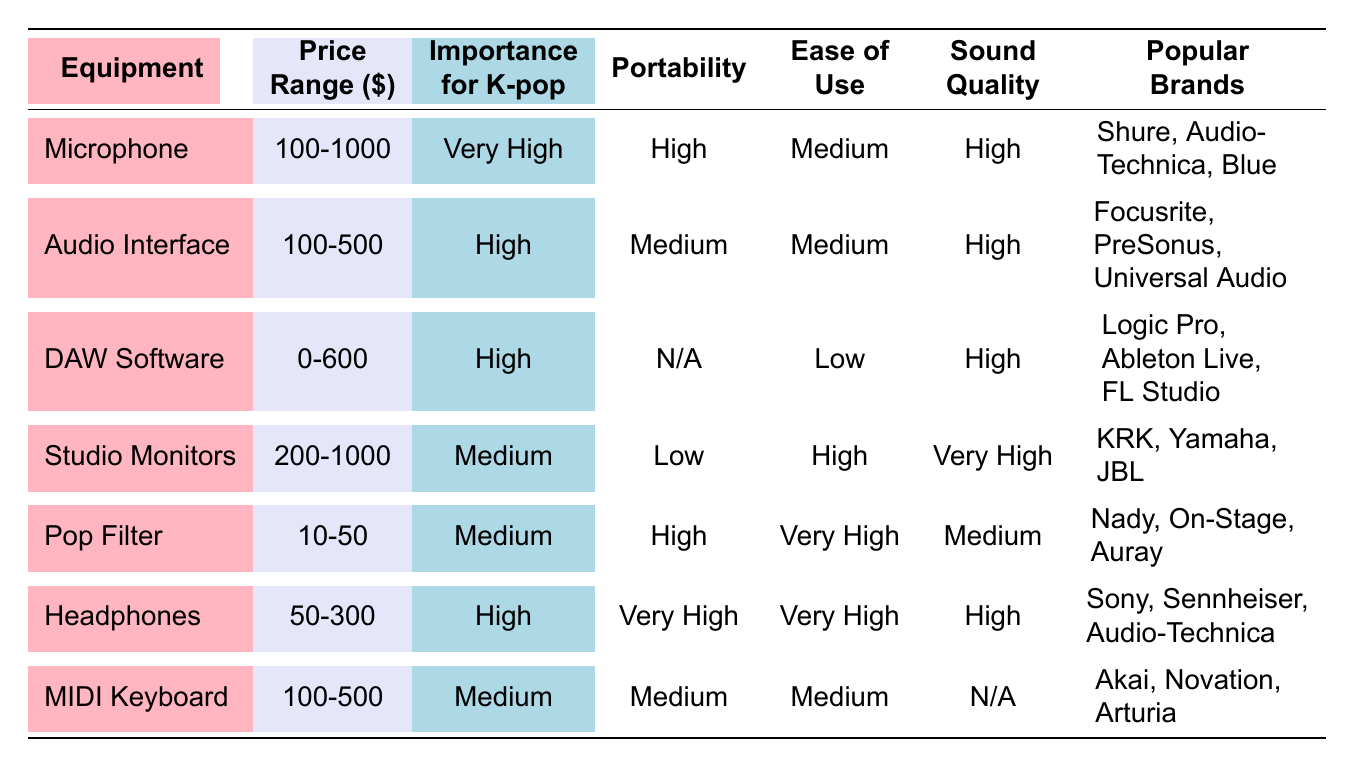What is the price range of a Pop Filter? The table lists the price range for a Pop Filter as "10-50" dollars.
Answer: 10-50 Which equipment has the highest sound quality rating? According to the table, Studio Monitors have the highest sound quality rating of "Very High."
Answer: Studio Monitors Is the importance of a Microphone for K-pop considered high? The table indicates that the importance of a Microphone for K-pop is rated as "Very High," so the answer is yes.
Answer: Yes What equipment has the lowest portability rating? The table shows that Studio Monitors have a portability rating of "Low," which is the lowest among the listed equipment.
Answer: Studio Monitors Does the DAW Software have an ease of use rating higher than the Audio Interface? The DAW Software has an ease of use rating of "Low," while the Audio Interface has "Medium." Since "Low" is not higher than "Medium," the answer is no.
Answer: No What is the average price range of all audio equipment listed? To find the average price range, we'll take all the price ranges into account: Microphone (100-1000), Audio Interface (100-500), DAW Software (0-600), Studio Monitors (200-1000), Pop Filter (10-50), Headphones (50-300), and MIDI Keyboard (100-500). Calculating the average range involves considering the minimum and maximum values separately. The minimum total is 100 + 100 + 0 + 200 + 10 + 50 + 100 = 560, and the maximum is 1000 + 500 + 600 + 1000 + 50 + 300 + 500 = 3950. Therefore, average minimum = 560/7 = 80 and maximum = 3950/7 = 564.285 which is rounded to approximately "80-564".
Answer: 80-564 Which piece of equipment is the most portable? The table indicates that Headphones have the highest portability rating of "Very High," making them the most portable equipment on the list.
Answer: Headphones 